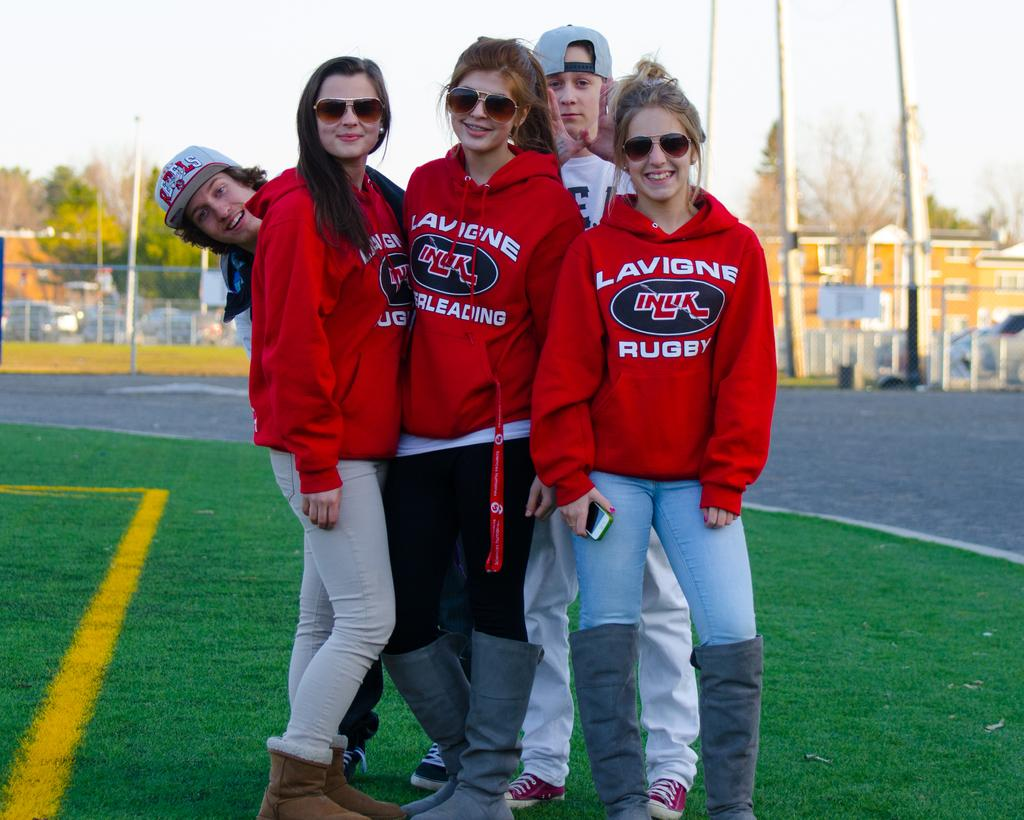Provide a one-sentence caption for the provided image. A group of people with red sweatshirts that say Lavigne Rugby. 